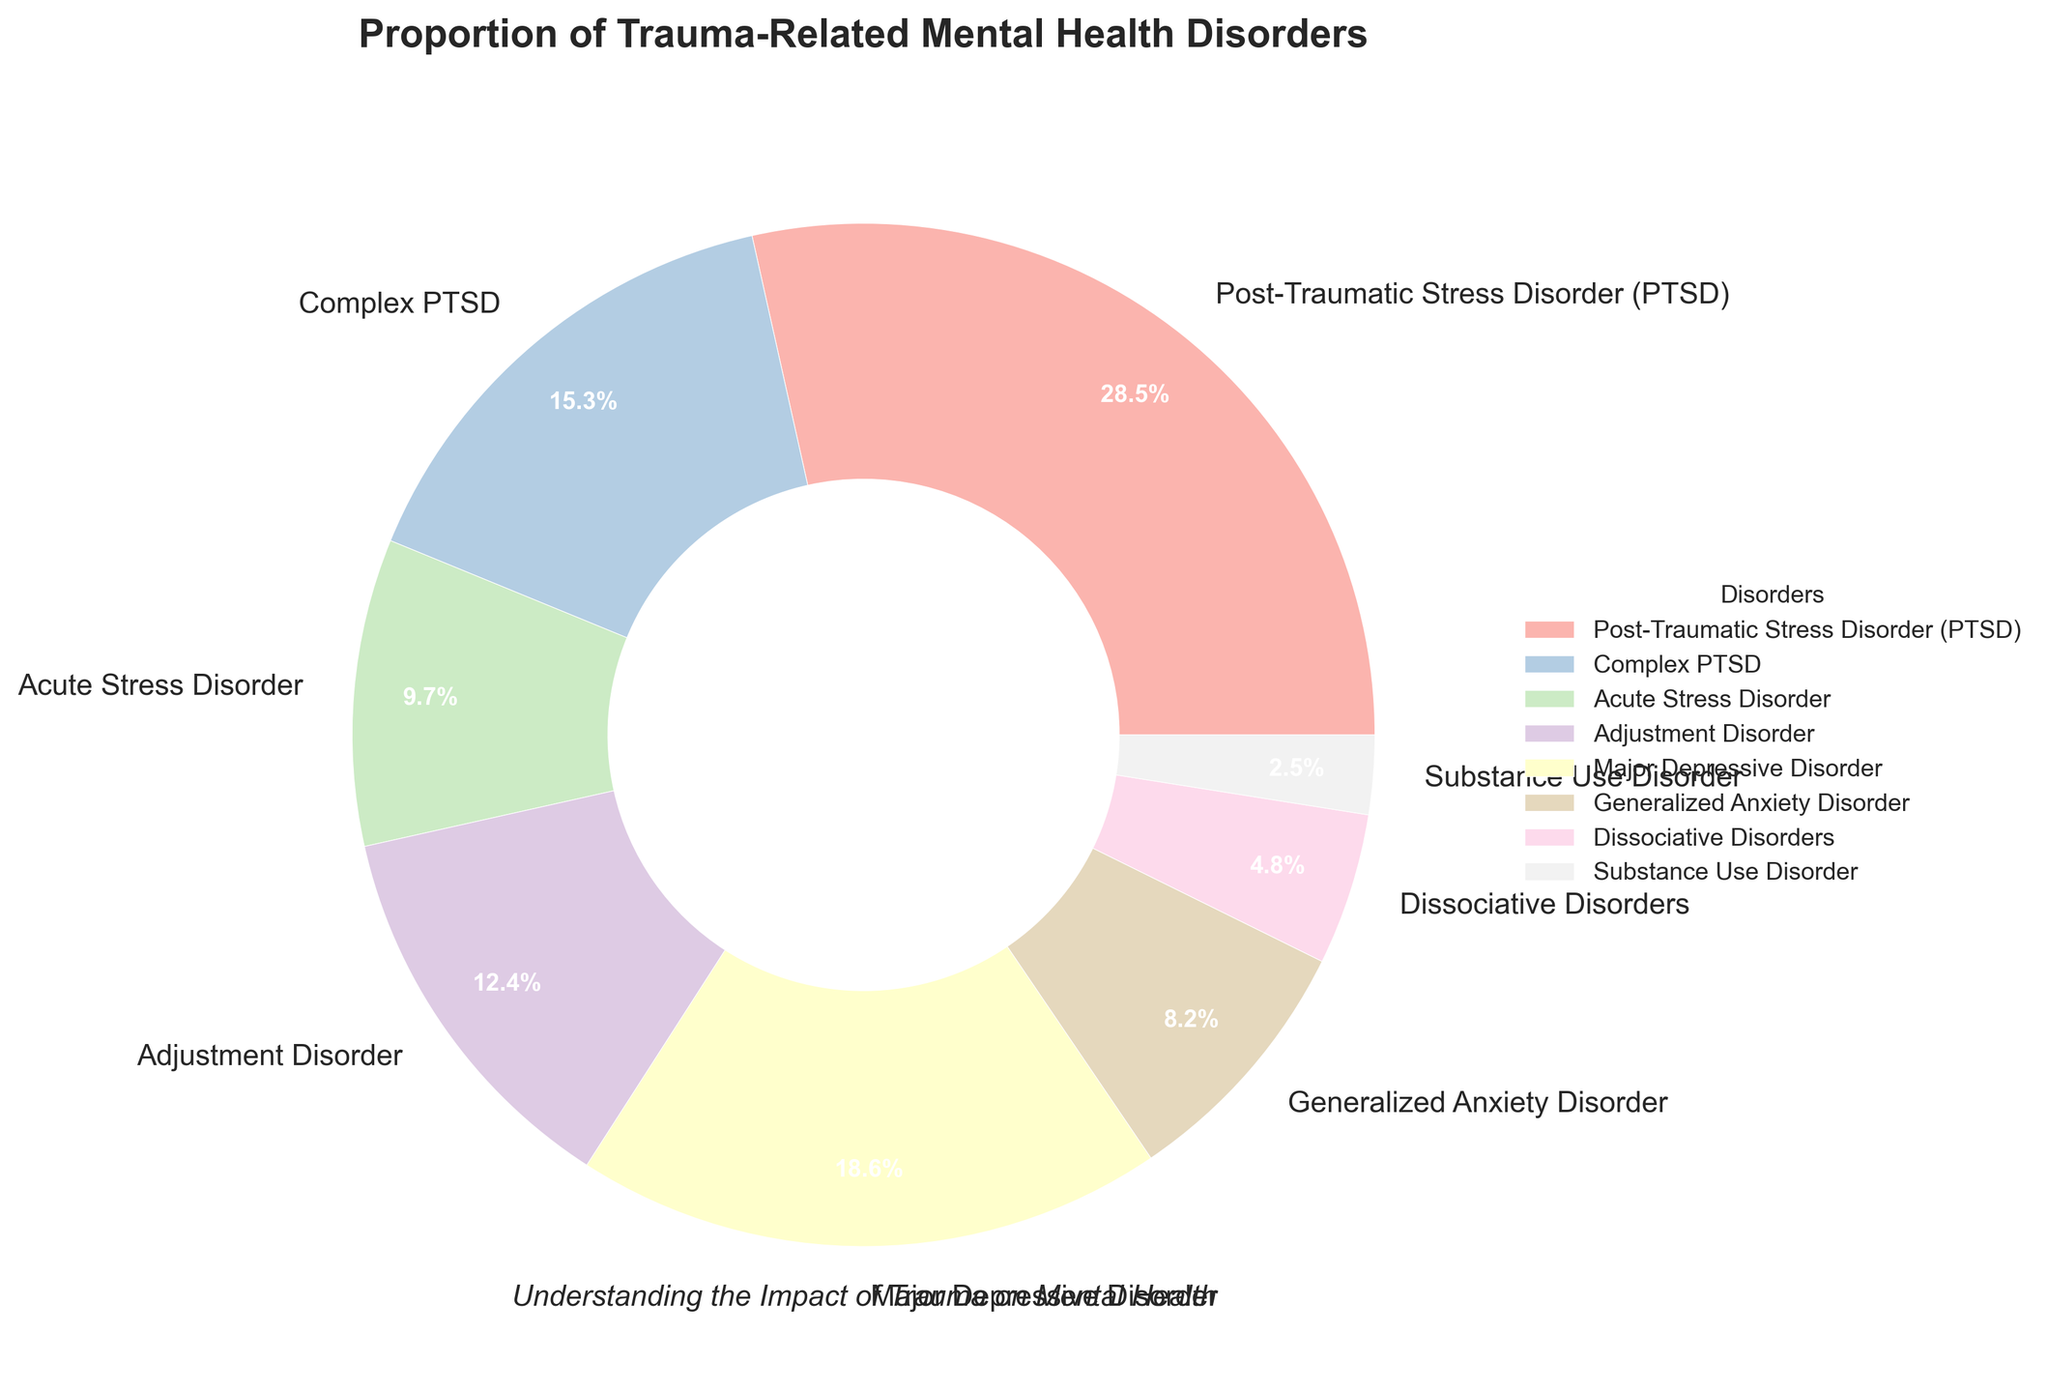What percentage of trauma-related mental health disorders is attributed to Post-Traumatic Stress Disorder (PTSD)? Look for the section on the pie chart labeled "Post-Traumatic Stress Disorder (PTSD)" and note the corresponding percentage.
Answer: 28.5% Which disorder has the highest proportion among the listed trauma-related mental health disorders? Identify the largest section in the pie chart by its size and the indicated percentage.
Answer: Post-Traumatic Stress Disorder (PTSD) What is the combined percentage of patients with PTSD and Major Depressive Disorder? Find the percentages for PTSD and Major Depressive Disorder on the pie chart, then add them together: 28.5% + 18.6%.
Answer: 47.1% Which disorder has a lower percentage, Acute Stress Disorder or Generalized Anxiety Disorder? Compare the percentages for Acute Stress Disorder (9.7%) and Generalized Anxiety Disorder (8.2%) displayed on the pie chart.
Answer: Generalized Anxiety Disorder What is the difference in percentage between Complex PTSD and Adjustment Disorder? Subtract the percentage of Adjustment Disorder from that of Complex PTSD: 15.3% - 12.4%.
Answer: 2.9% How many disorders constitute more than 15% each of the total trauma-related mental health disorders? Count the sections of the pie chart that represent more than 15% each. The sections are PTSD (28.5%) and Major Depressive Disorder (18.6%).
Answer: 2 What is the percentage of disorders not directly related to stress (i.e., excluding PTSD, Complex PTSD, and Acute Stress Disorder)? Add the percentages of Adjustment Disorder, Major Depressive Disorder, Generalized Anxiety Disorder, Dissociative Disorders, and Substance Use Disorder. 12.4% + 18.6% + 8.2% + 4.8% + 2.5%.
Answer: 46.5% Which color section represents Dissociative Disorders in the pie chart? Identify the section labeled "Dissociative Disorders" and describe its color based on the visualization. (The color details should match the custom palette generated.)
Answer: Light purple (based on the Pastel1 colormap) How does the proportion of Generalized Anxiety Disorder compare to Substance Use Disorder? Compare the percentages of Generalized Anxiety Disorder (8.2%) and Substance Use Disorder (2.5%) to see which is higher.
Answer: Generalized Anxiety Disorder What is the combined total percentage of PTSD, Complex PTSD, and Acute Stress Disorder? Add the percentages of PTSD (28.5%), Complex PTSD (15.3%), and Acute Stress Disorder (9.7%). 28.5% + 15.3% + 9.7%.
Answer: 53.5% 